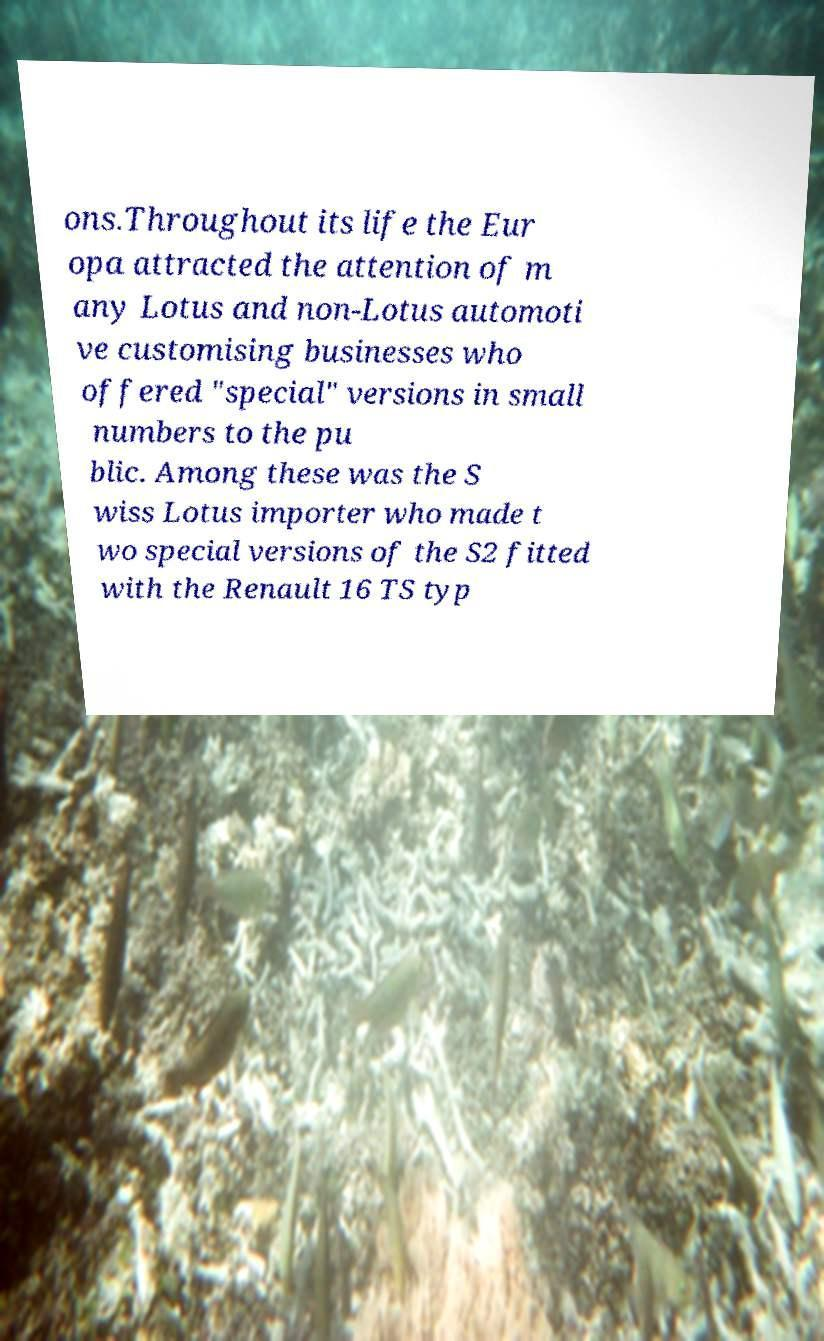I need the written content from this picture converted into text. Can you do that? ons.Throughout its life the Eur opa attracted the attention of m any Lotus and non-Lotus automoti ve customising businesses who offered "special" versions in small numbers to the pu blic. Among these was the S wiss Lotus importer who made t wo special versions of the S2 fitted with the Renault 16 TS typ 